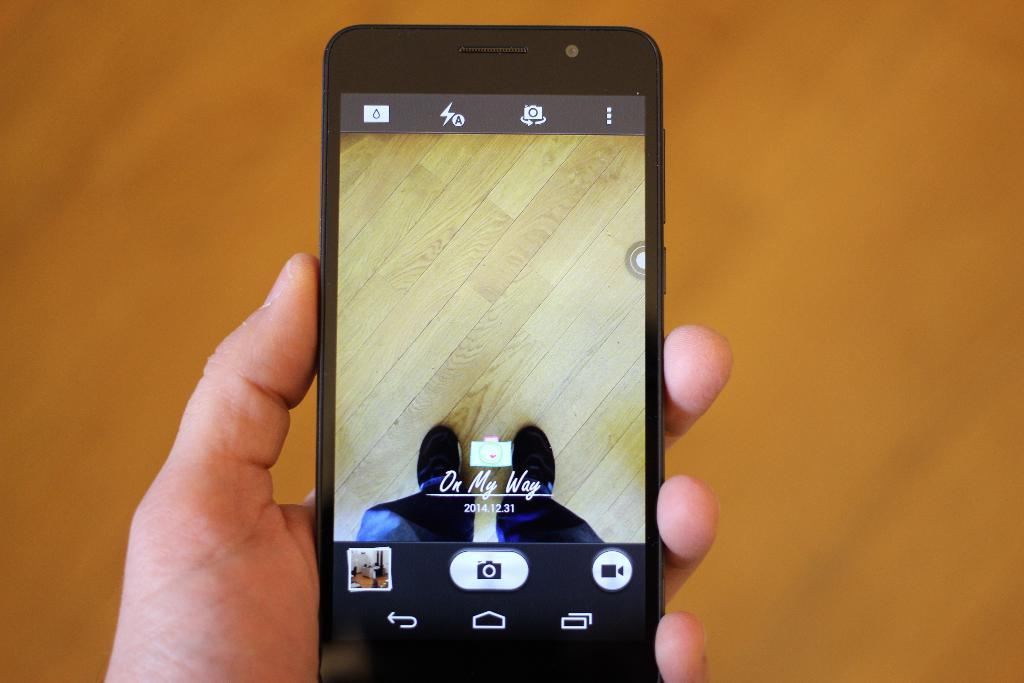<image>
Offer a succinct explanation of the picture presented. a phone that says on my way on it 